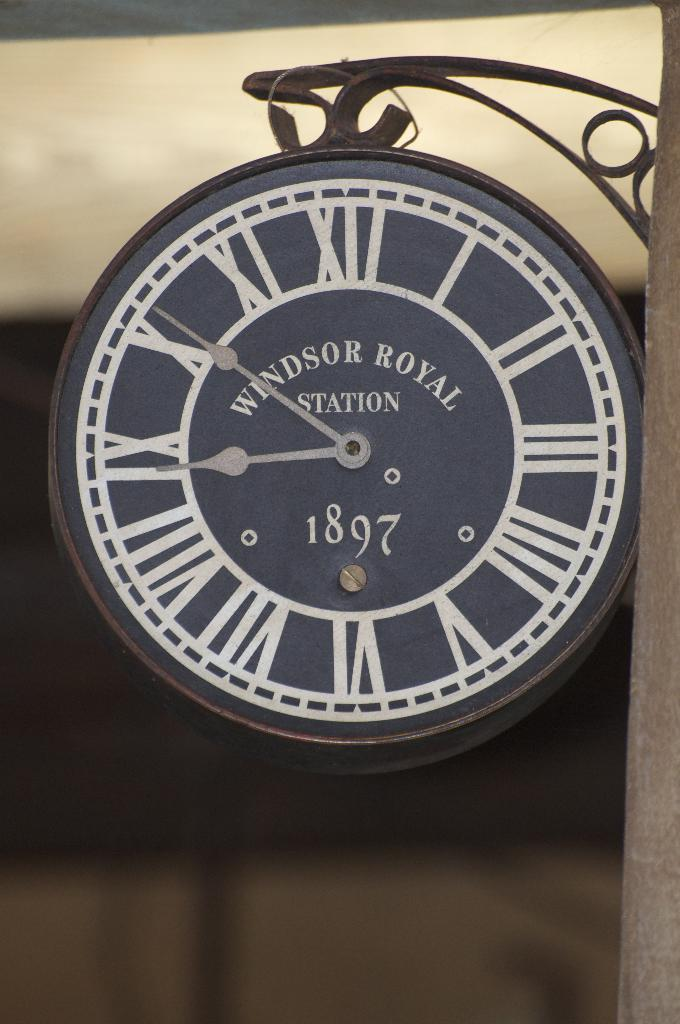<image>
Provide a brief description of the given image. A Windsor Royal station clocks is hanging from a metal post. 